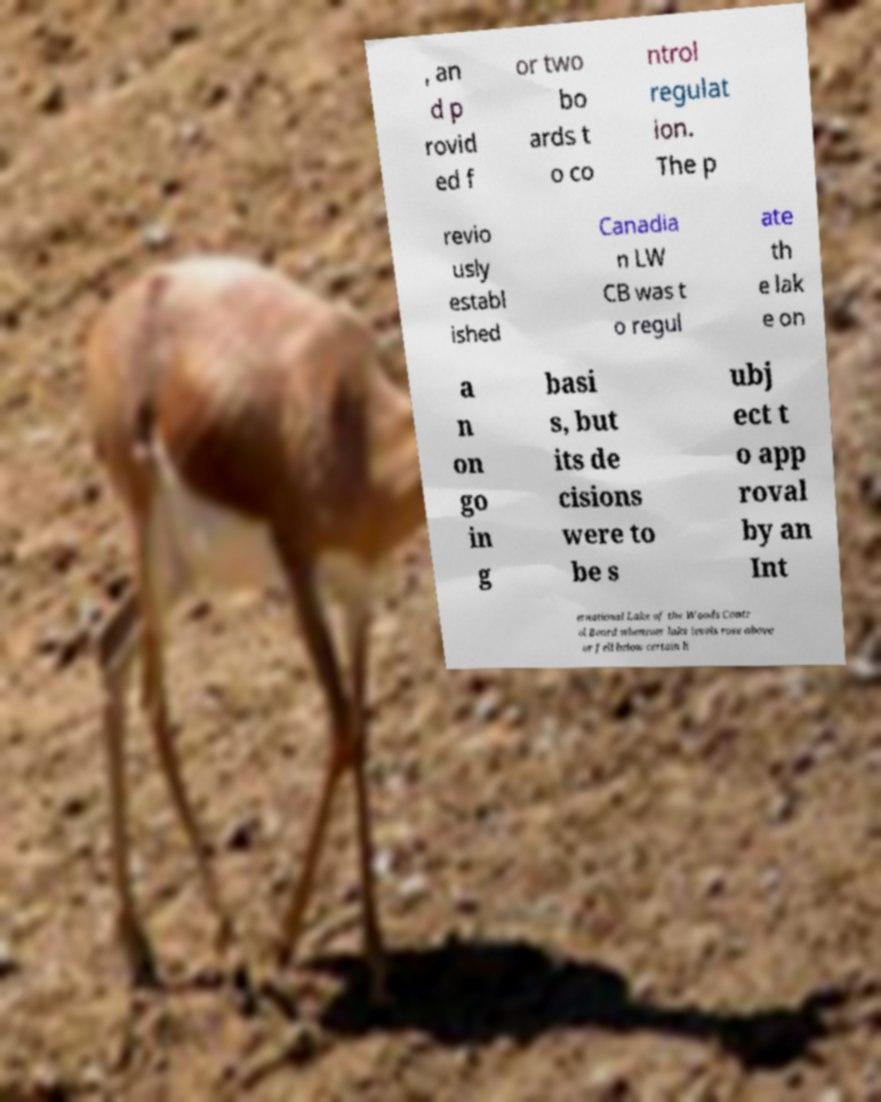There's text embedded in this image that I need extracted. Can you transcribe it verbatim? , an d p rovid ed f or two bo ards t o co ntrol regulat ion. The p revio usly establ ished Canadia n LW CB was t o regul ate th e lak e on a n on go in g basi s, but its de cisions were to be s ubj ect t o app roval by an Int ernational Lake of the Woods Contr ol Board whenever lake levels rose above or fell below certain li 